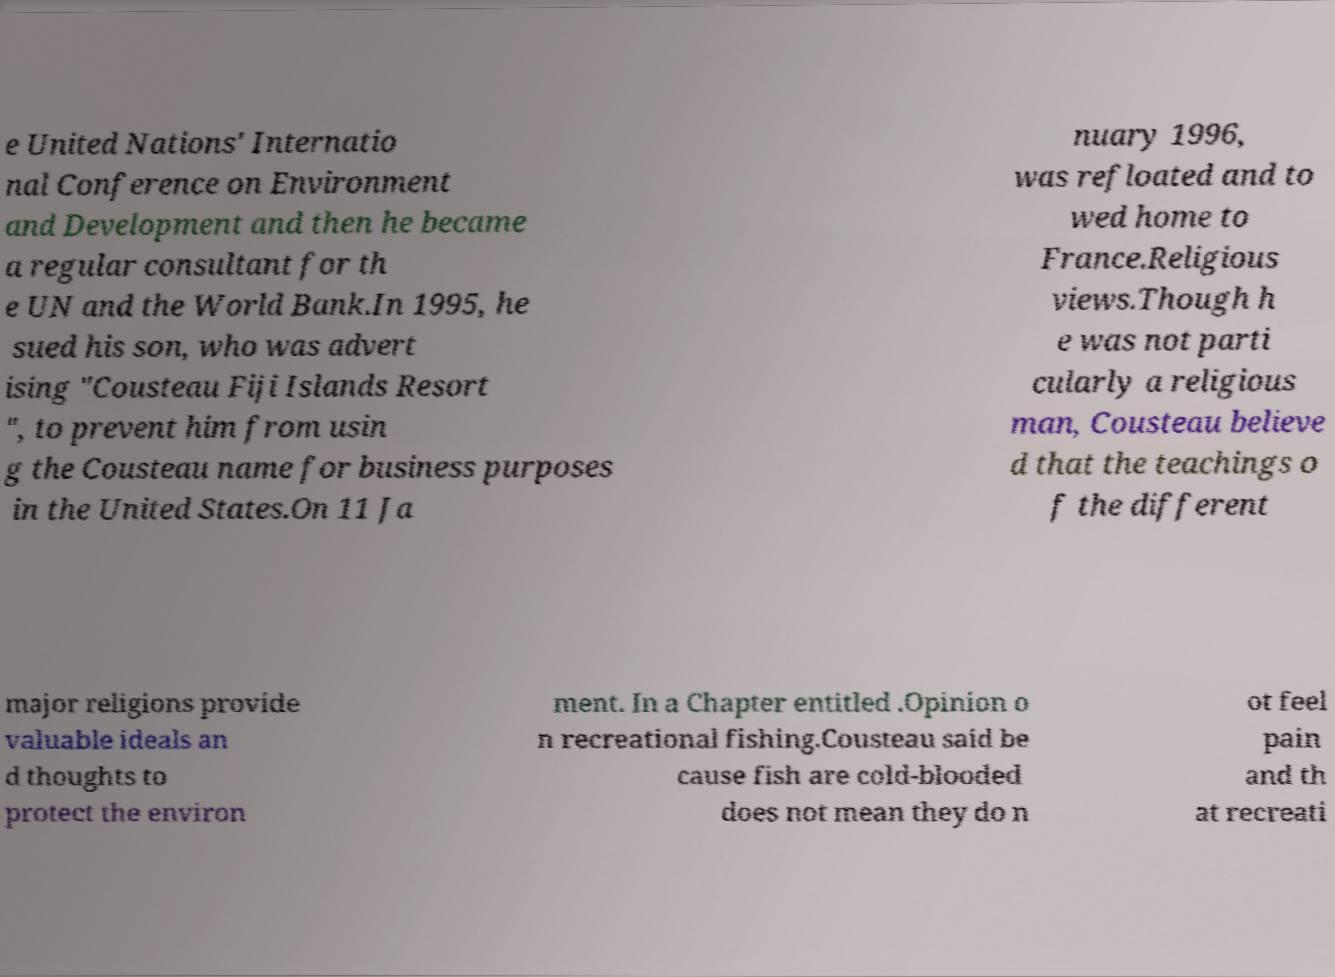Can you accurately transcribe the text from the provided image for me? e United Nations' Internatio nal Conference on Environment and Development and then he became a regular consultant for th e UN and the World Bank.In 1995, he sued his son, who was advert ising "Cousteau Fiji Islands Resort ", to prevent him from usin g the Cousteau name for business purposes in the United States.On 11 Ja nuary 1996, was refloated and to wed home to France.Religious views.Though h e was not parti cularly a religious man, Cousteau believe d that the teachings o f the different major religions provide valuable ideals an d thoughts to protect the environ ment. In a Chapter entitled .Opinion o n recreational fishing.Cousteau said be cause fish are cold-blooded does not mean they do n ot feel pain and th at recreati 